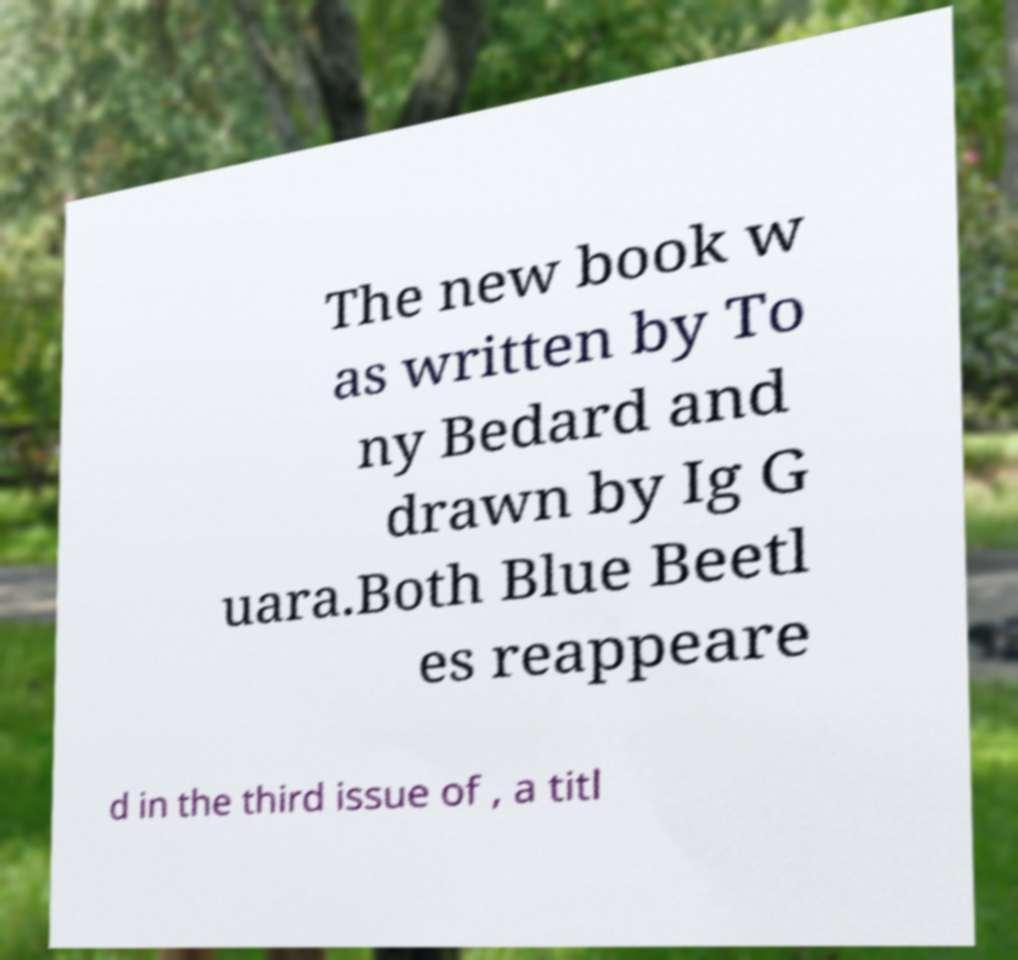Could you extract and type out the text from this image? The new book w as written by To ny Bedard and drawn by Ig G uara.Both Blue Beetl es reappeare d in the third issue of , a titl 